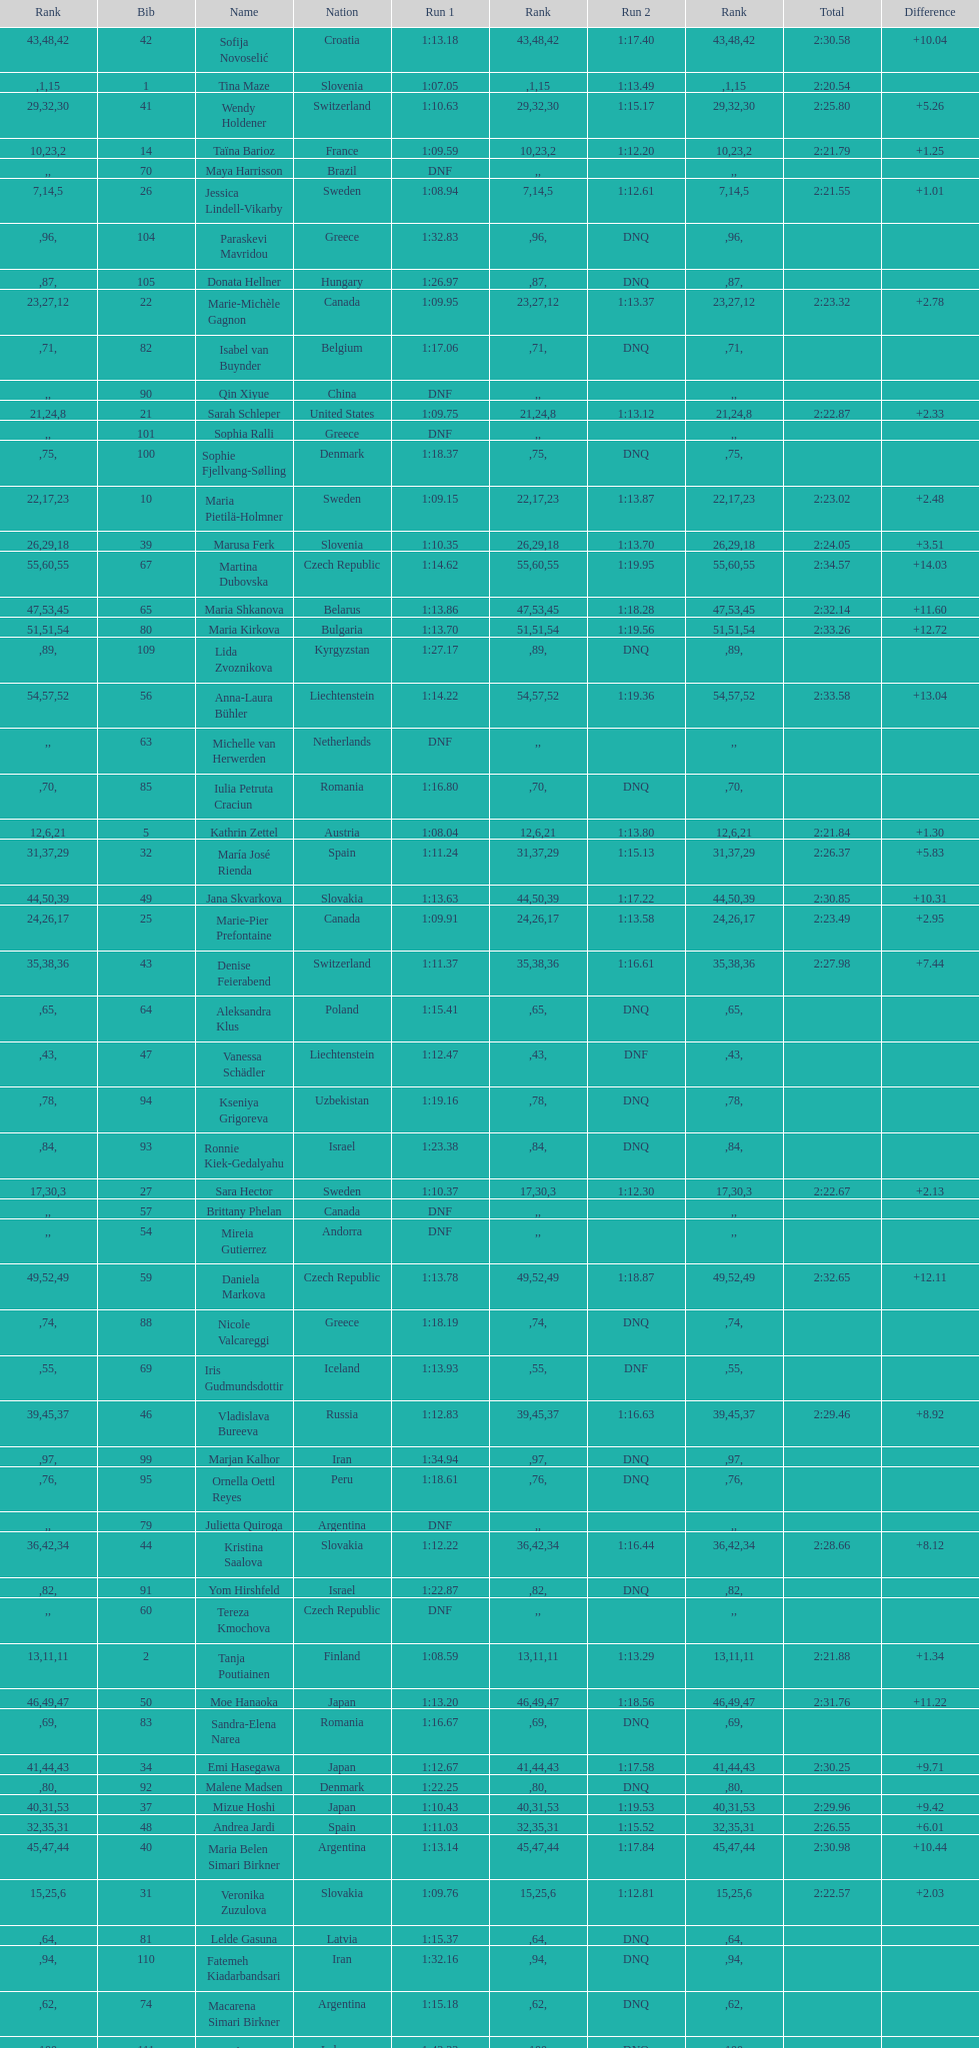What is the last nation to be ranked? Czech Republic. 